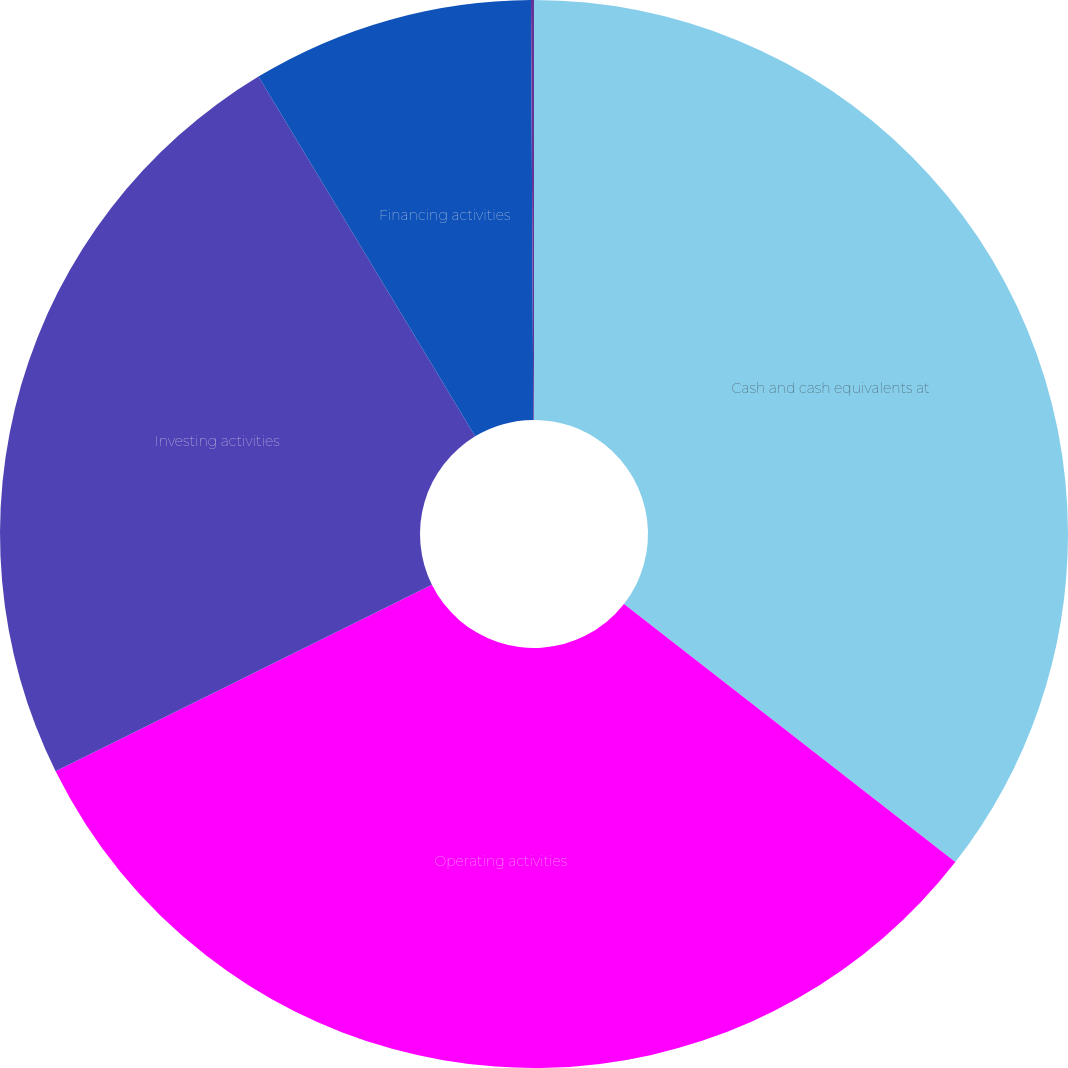<chart> <loc_0><loc_0><loc_500><loc_500><pie_chart><fcel>Cash and cash equivalents at<fcel>Operating activities<fcel>Investing activities<fcel>Financing activities<fcel>Net increase (decrease) in<nl><fcel>35.53%<fcel>32.14%<fcel>23.7%<fcel>8.54%<fcel>0.09%<nl></chart> 